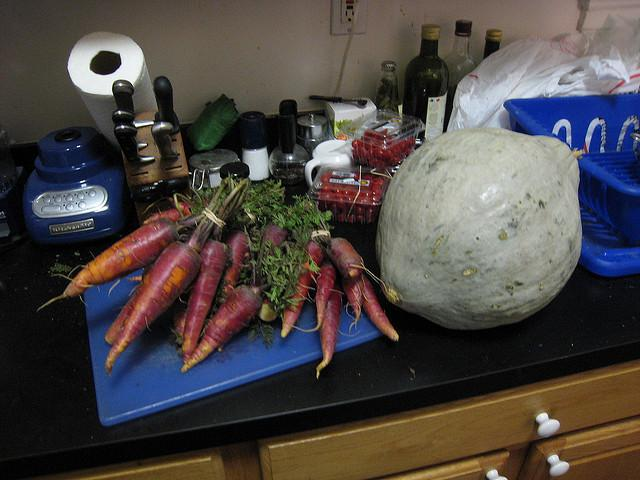Which food is rich in vitamin A? carrot 